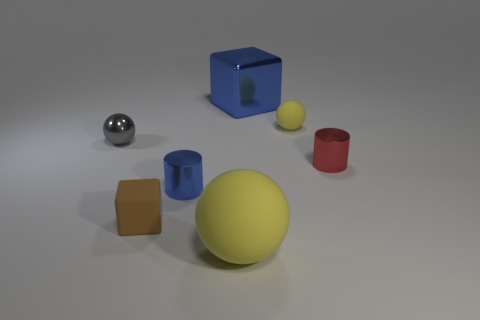Which two objects would fit inside each other? The blue cylinder could fit inside the hollow blue cube because of the cylinder's smaller diameter and height. 